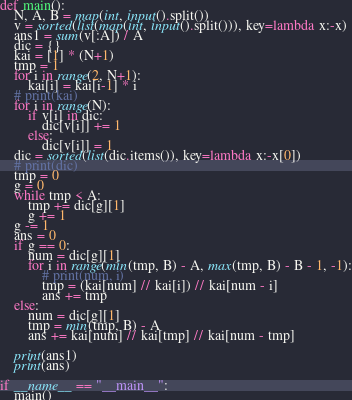<code> <loc_0><loc_0><loc_500><loc_500><_Python_>def main():
    N, A, B = map(int, input().split())
    v = sorted(list(map(int, input().split())), key=lambda x:-x)
    ans1 = sum(v[:A]) / A
    dic = {}
    kai = [1] * (N+1)
    tmp = 1
    for i in range(2, N+1):
        kai[i] = kai[i-1] * i
    # print(kai)
    for i in range(N):
        if v[i] in dic:
            dic[v[i]] += 1
        else:
            dic[v[i]] = 1
    dic = sorted(list(dic.items()), key=lambda x:-x[0])
    # print(dic)
    tmp = 0
    g = 0
    while tmp < A:
        tmp += dic[g][1]
        g += 1
    g -= 1
    ans = 0
    if g == 0:
        num = dic[g][1]
        for i in range(min(tmp, B) - A, max(tmp, B) - B - 1, -1):
            # print(num, i)
            tmp = (kai[num] // kai[i]) // kai[num - i]
            ans += tmp
    else:
        num = dic[g][1]
        tmp = min(tmp, B) - A
        ans += kai[num] // kai[tmp] // kai[num - tmp]
    
    print(ans1)
    print(ans)
    
if __name__ == "__main__":
    main()</code> 